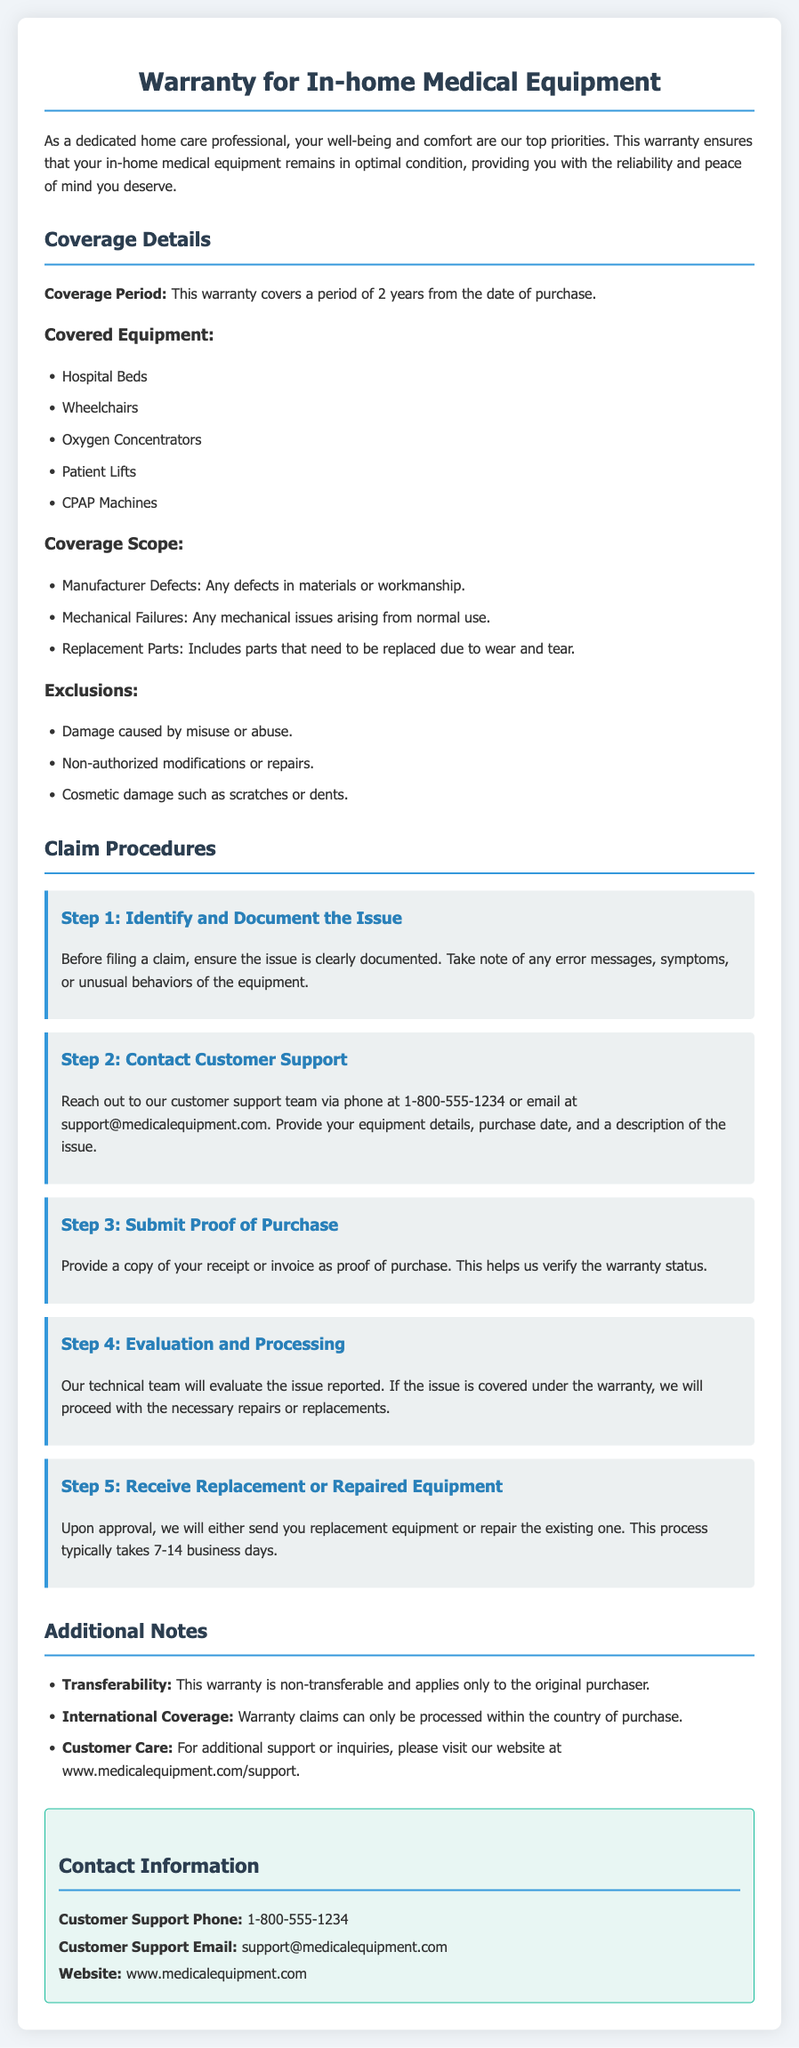What is the coverage period of the warranty? The coverage period is mentioned clearly within the document as the duration for which the warranty is valid, which is 2 years.
Answer: 2 years What types of equipment are covered under this warranty? The document lists specific types of medical equipment that are covered, including Hospital Beds, Wheelchairs, Oxygen Concentrators, Patient Lifts, and CPAP Machines.
Answer: Hospital Beds, Wheelchairs, Oxygen Concentrators, Patient Lifts, CPAP Machines What is not covered under the warranty? The document provides a list of exclusions that detail specific scenarios in which the warranty would not apply, including damage caused by misuse or abuse.
Answer: Damage caused by misuse or abuse What is the third step in the claim procedures? The document clearly outlines the steps involved in filing a claim, with the third step specifically involving the submission of proof of purchase.
Answer: Submit Proof of Purchase How many steps are outlined in the claim procedures? The document enumerates the steps to be taken when making a warranty claim, explicitly stating the total number of steps as they are presented sequentially.
Answer: 5 What should you provide when contacting customer support? The document advises on what information is required when reaching out to customer support, which should include equipment details, purchase date, and a description of the issue.
Answer: Equipment details, purchase date, description of the issue How long does it typically take to receive repaired or replacement equipment? The document specifies the estimated time frame for processing claims and sending the repaired or replacement equipment, giving an idea of what to expect regarding the duration.
Answer: 7-14 business days Is the warranty transferable to another person? The document specifically mentions whether the warranty can be transferred to someone else, informing the reader about the ownership status of the warranty itself.
Answer: Non-transferable 